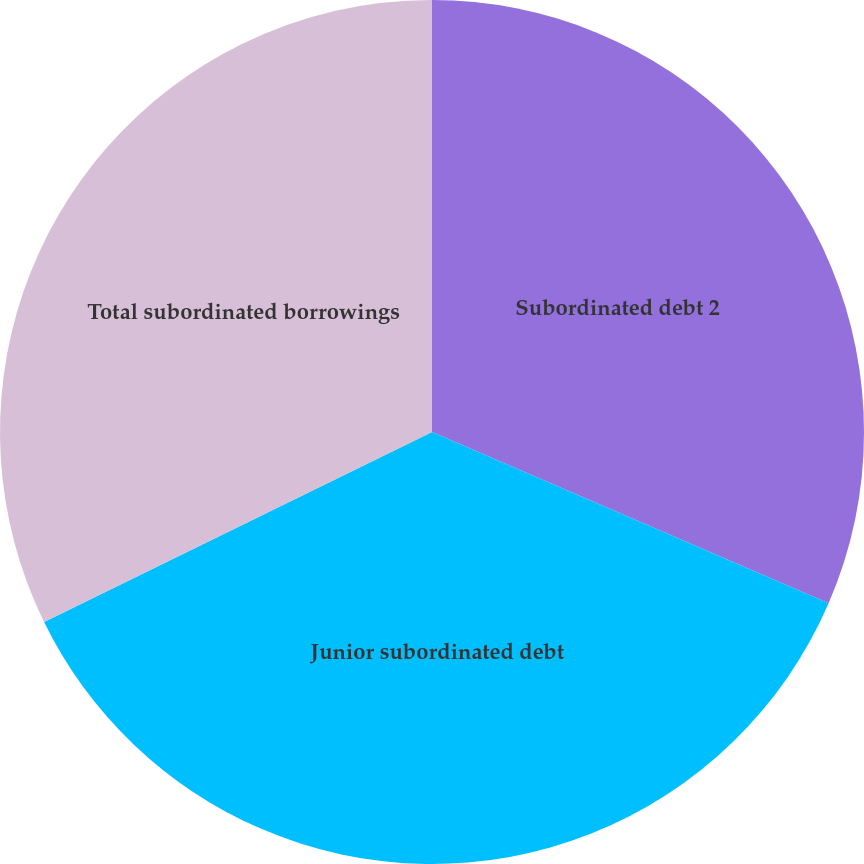Convert chart to OTSL. <chart><loc_0><loc_0><loc_500><loc_500><pie_chart><fcel>Subordinated debt 2<fcel>Junior subordinated debt<fcel>Total subordinated borrowings<nl><fcel>31.49%<fcel>36.26%<fcel>32.25%<nl></chart> 